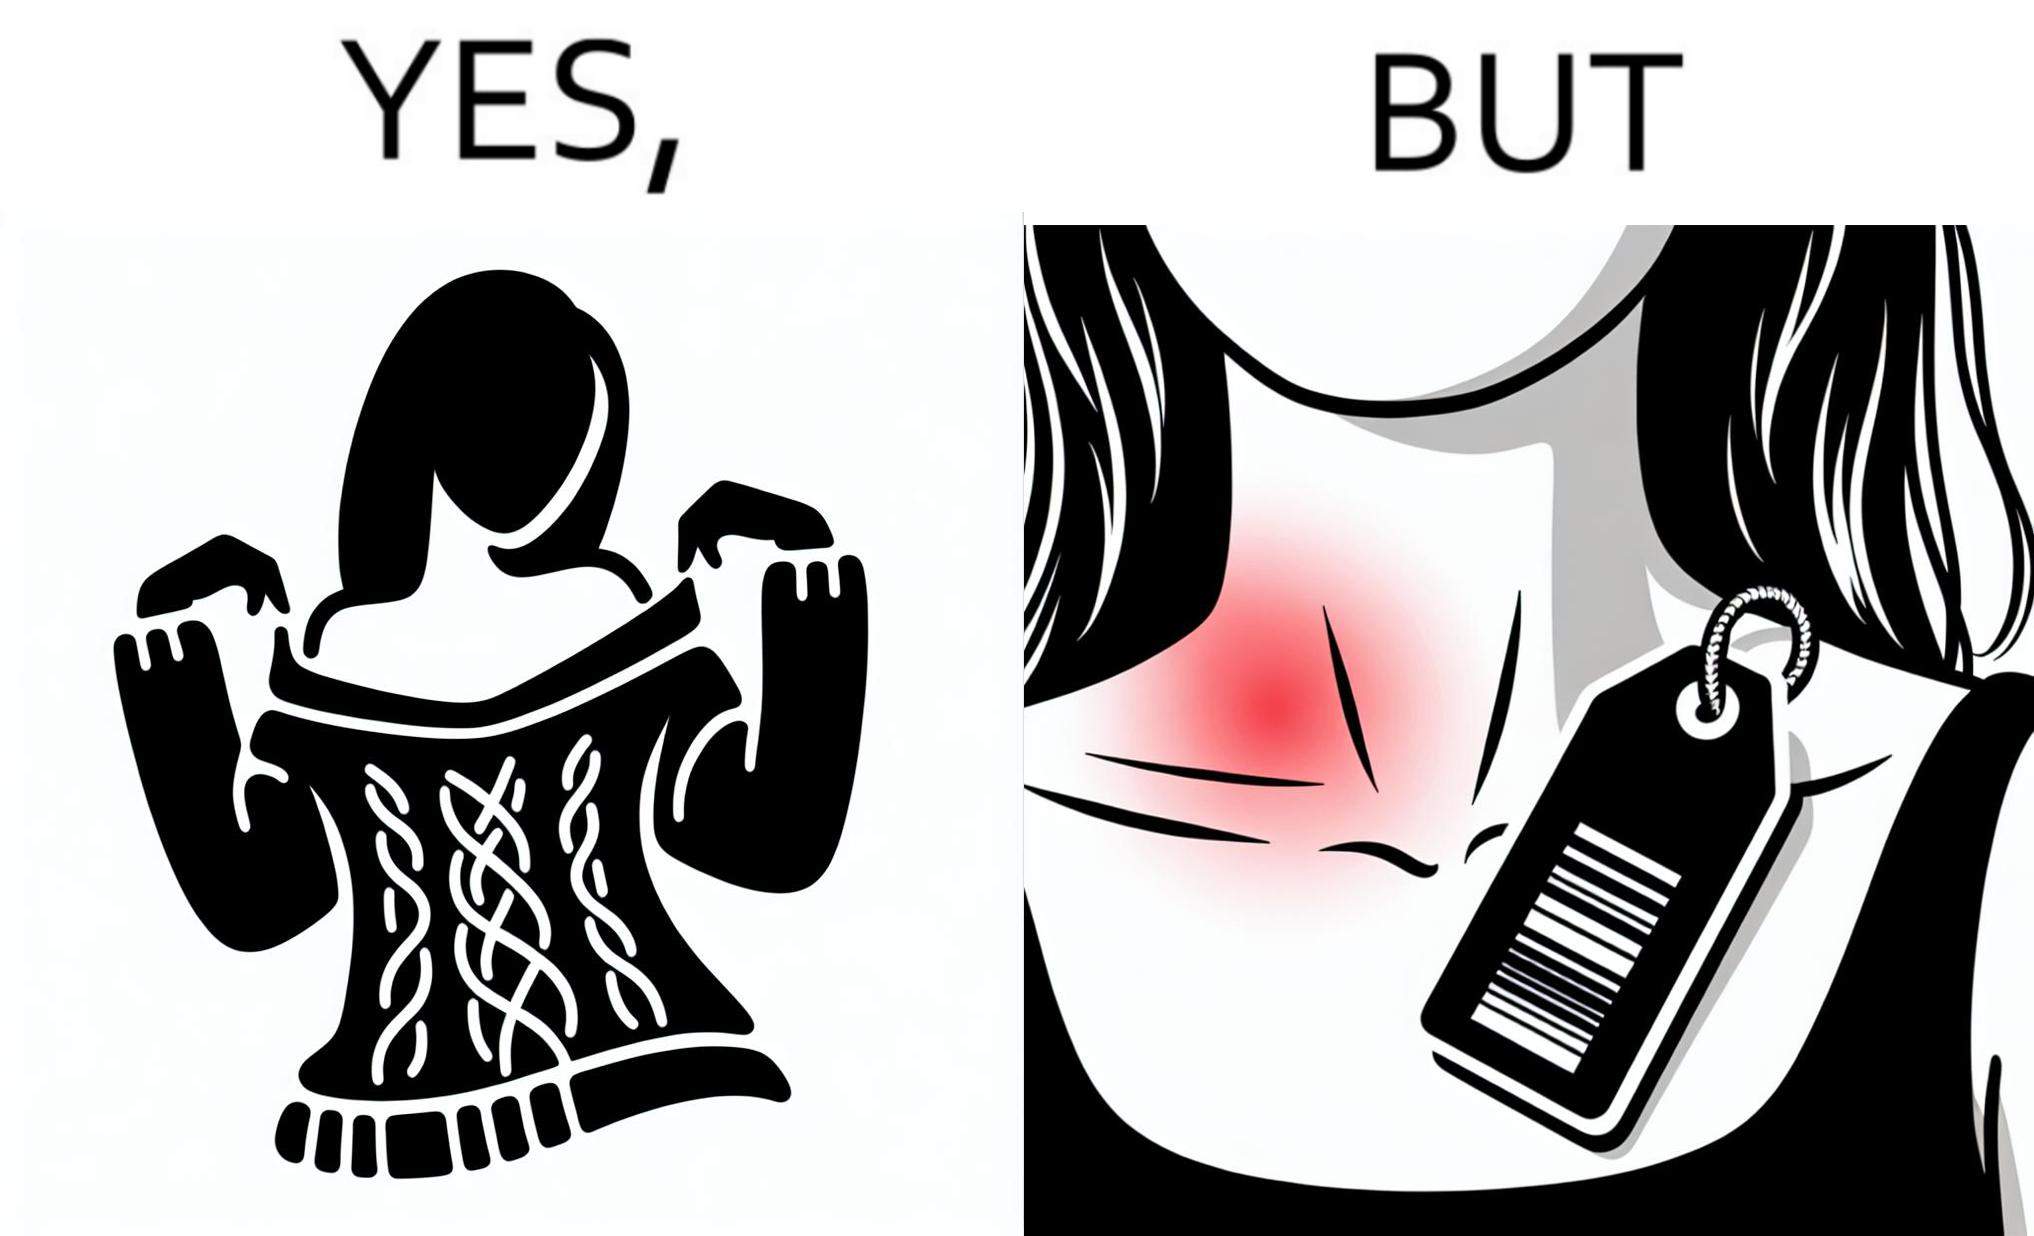Is there satirical content in this image? Yes, this image is satirical. 